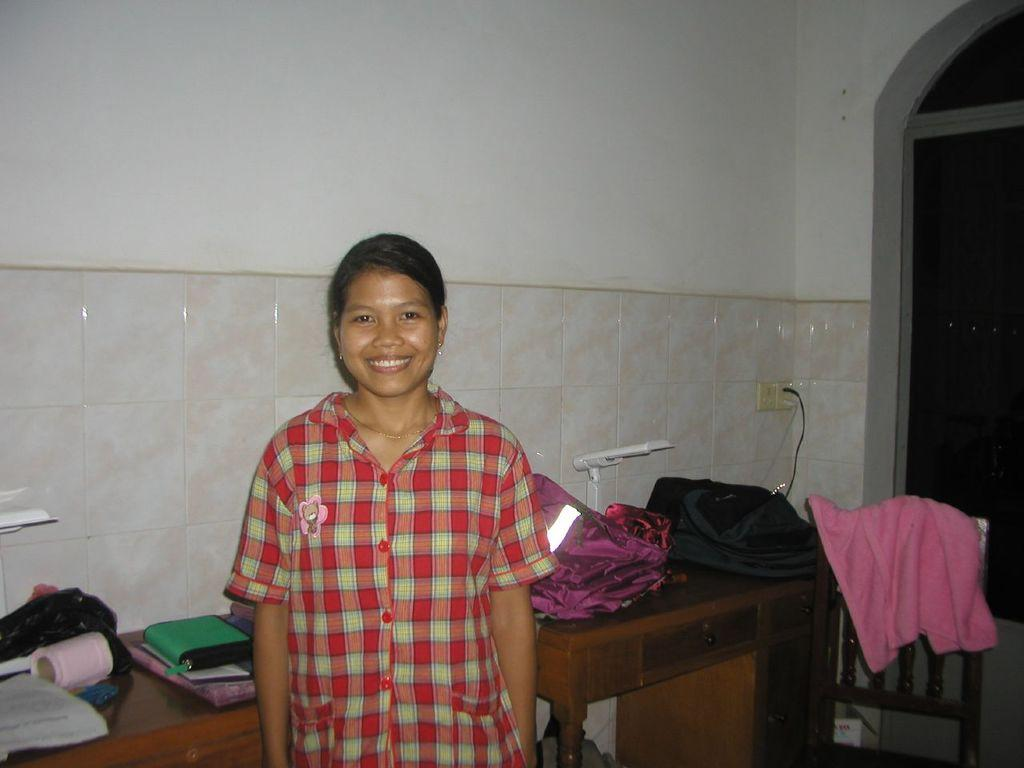What is the main subject of the image? The main subject of the image is a woman. What is the woman doing in the image? The woman is standing and smiling in the image. What objects can be seen in the image besides the woman? There are books, clothes, a chair, tables, and a switch board in the image. What can be seen in the background of the image? There is a wall in the background of the image. What type of nation is represented by the flag in the image? There is no flag present in the image, so it is not possible to determine which nation might be represented. How many kittens can be seen playing with the clothes in the image? There are no kittens present in the image, so it is not possible to determine how many might be playing with the clothes. 